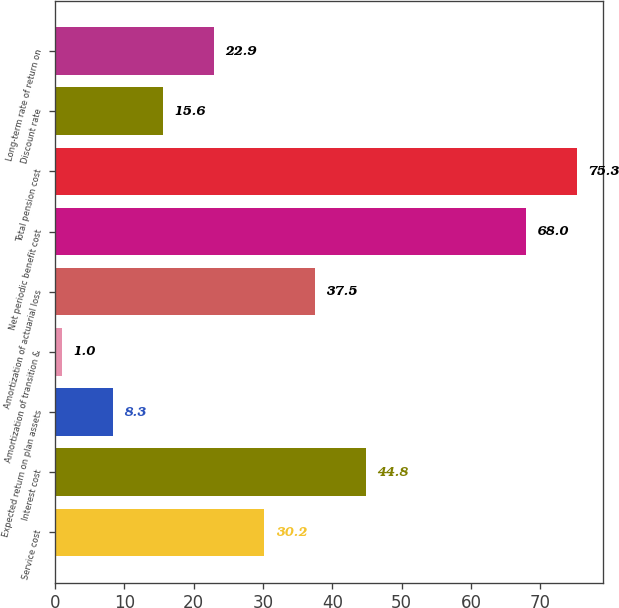Convert chart. <chart><loc_0><loc_0><loc_500><loc_500><bar_chart><fcel>Service cost<fcel>Interest cost<fcel>Expected return on plan assets<fcel>Amortization of transition &<fcel>Amortization of actuarial loss<fcel>Net periodic benefit cost<fcel>Total pension cost<fcel>Discount rate<fcel>Long-term rate of return on<nl><fcel>30.2<fcel>44.8<fcel>8.3<fcel>1<fcel>37.5<fcel>68<fcel>75.3<fcel>15.6<fcel>22.9<nl></chart> 